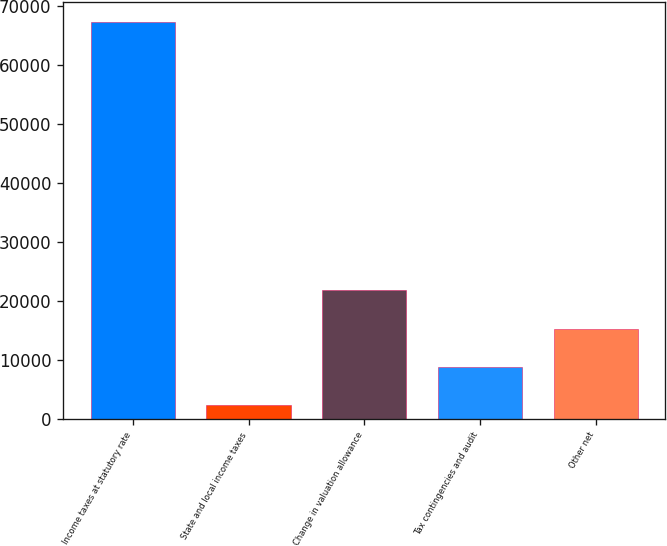Convert chart. <chart><loc_0><loc_0><loc_500><loc_500><bar_chart><fcel>Income taxes at statutory rate<fcel>State and local income taxes<fcel>Change in valuation allowance<fcel>Tax contingencies and audit<fcel>Other net<nl><fcel>67427<fcel>2358<fcel>21878.7<fcel>8864.9<fcel>15371.8<nl></chart> 